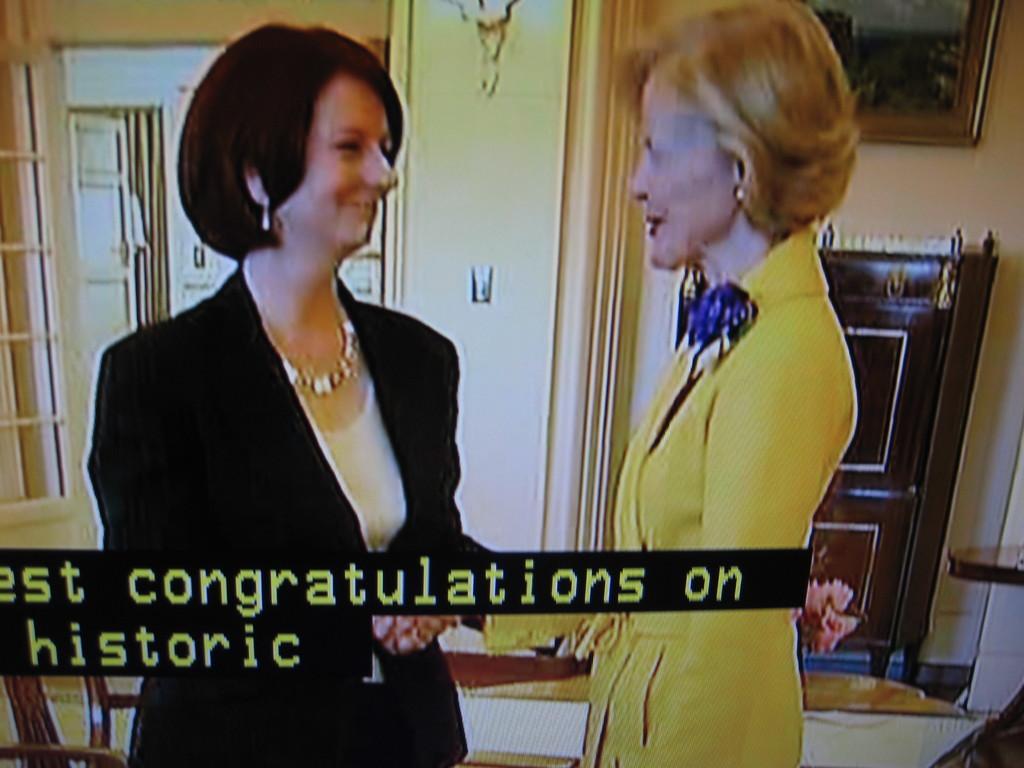Please provide a concise description of this image. In this image I can see two people are standing and wearing white, yellow and black color dresses. Back I can see window, few objects and frame is attached to the wall. 